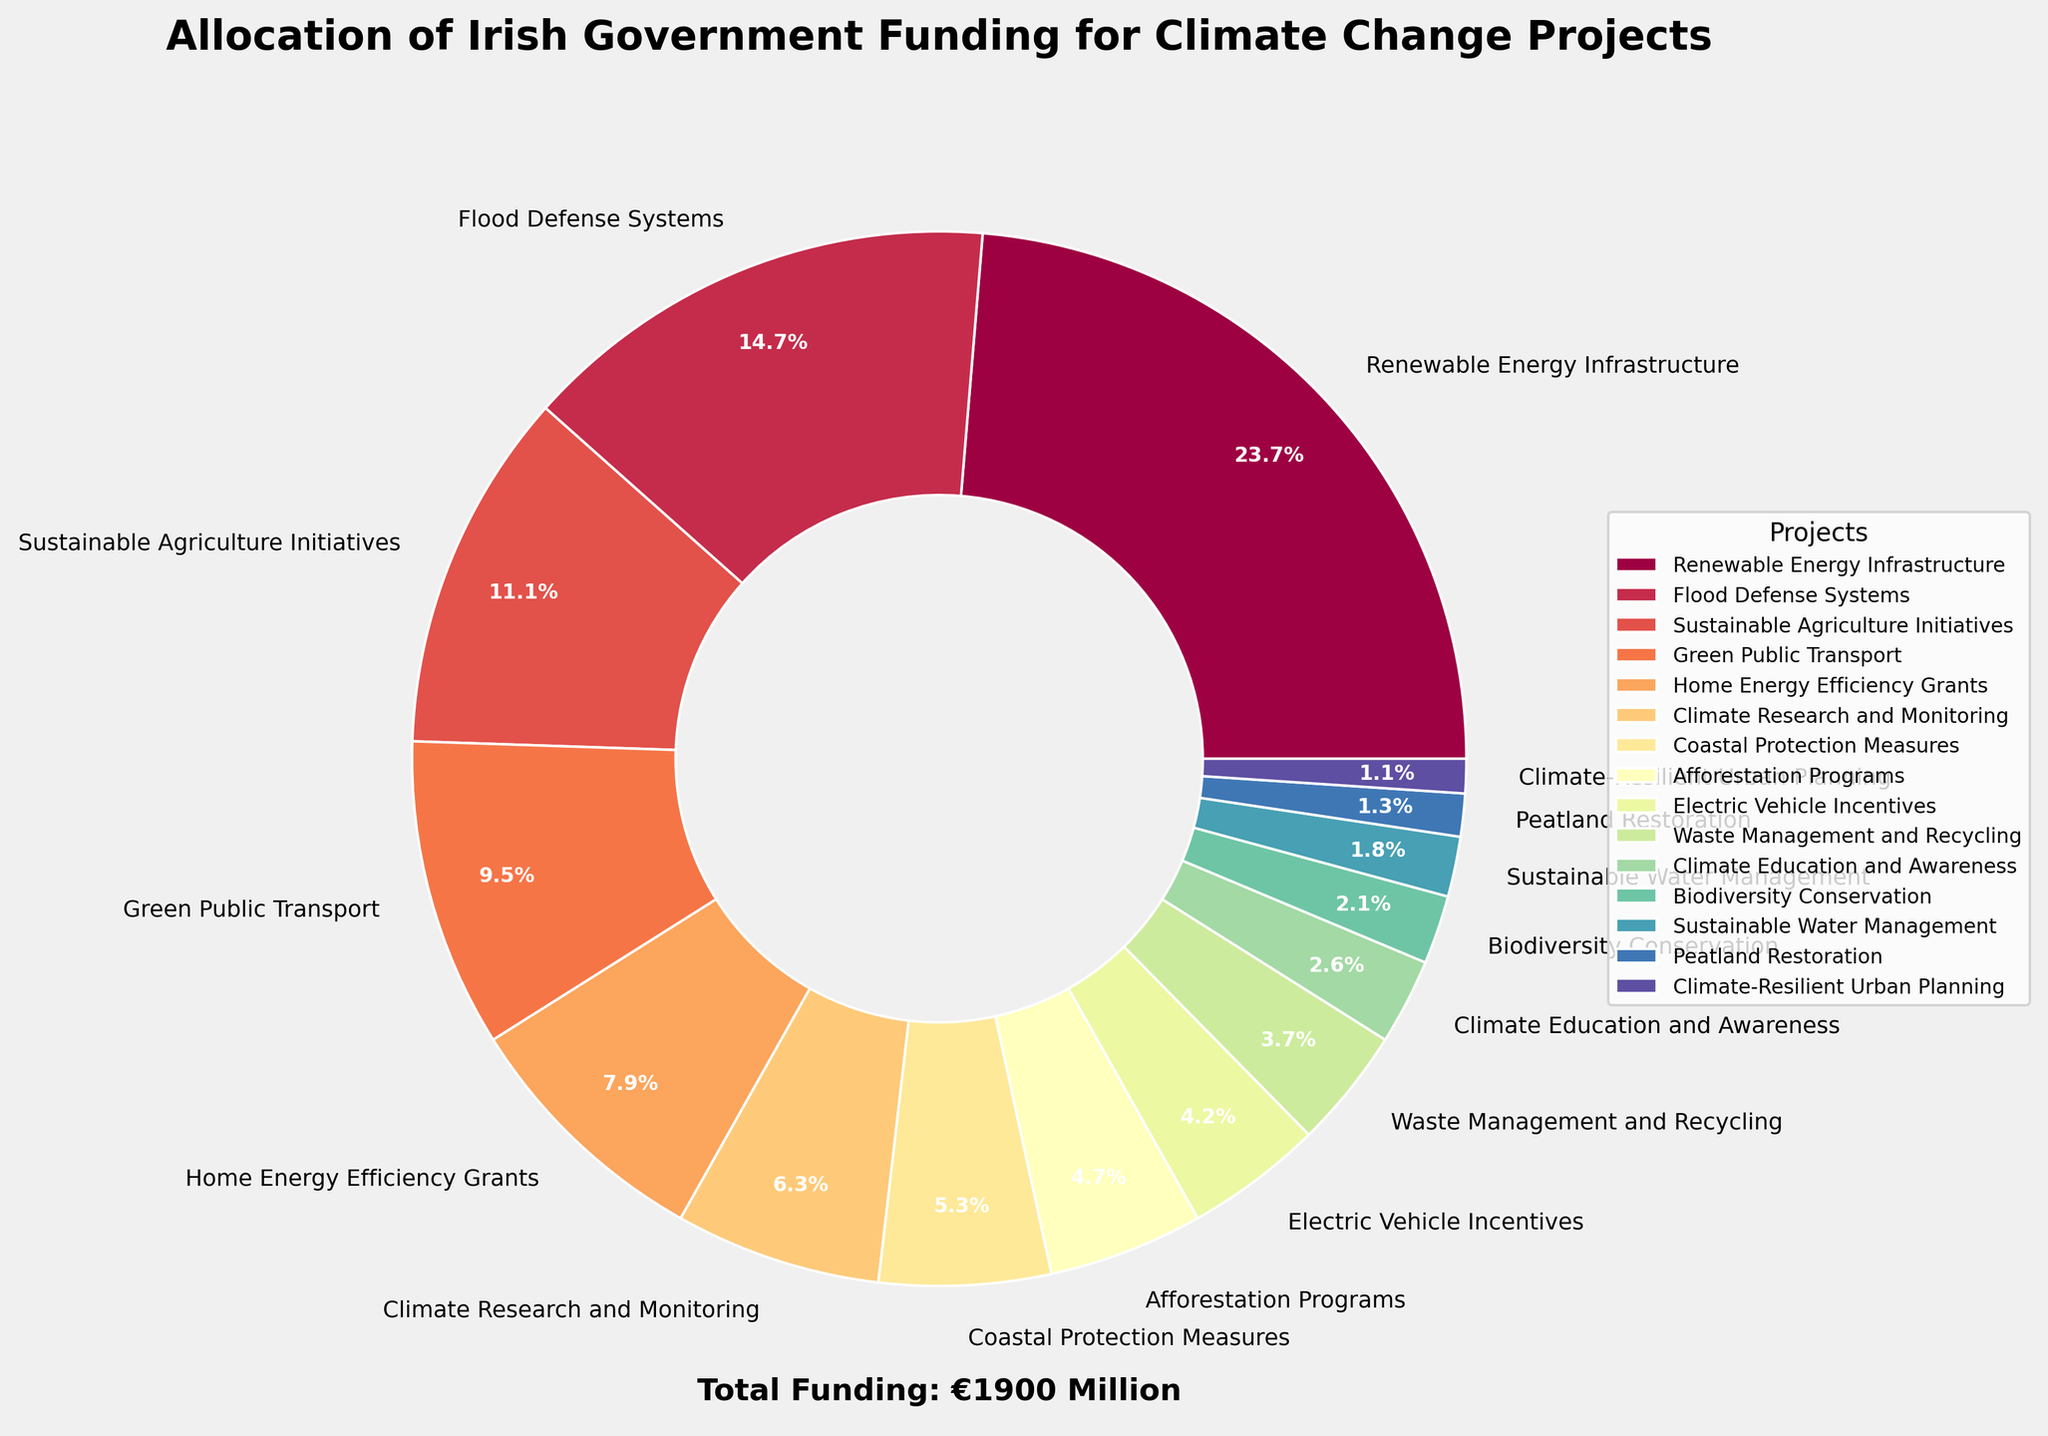Which project received the highest funding? The pie chart indicates that the largest slice corresponds to Renewable Energy Infrastructure.
Answer: Renewable Energy Infrastructure What is the funding gap between Renewable Energy Infrastructure and Flood Defense Systems? Renewable Energy Infrastructure received €450 million, while Flood Defense Systems got €280 million. The difference is 450 - 280 = 170.
Answer: €170 million How much total funding was allocated to Green Public Transport and Home Energy Efficiency Grants? Green Public Transport received €180 million, and Home Energy Efficiency Grants received €150 million. The total is 180 + 150 = 330.
Answer: €330 million Which projects received less funding than Climate Research and Monitoring? Climate Research and Monitoring got €120 million. Lower amounts were allocated to Coastal Protection Measures (€100 million), Afforestation Programs (€90 million), Electric Vehicle Incentives (€80 million), and so on.
Answer: Coastal Protection Measures, Afforestation Programs, Electric Vehicle Incentives, Waste Management and Recycling, Climate Education and Awareness, Biodiversity Conservation, Sustainable Water Management, Peatland Restoration, Climate-Resilient Urban Planning What percentage of the total funding is allocated to Afforestation Programs? The pie chart shows percentages, and Afforestation Programs received 90 / 1860 * 100 ≈ 4.8%.
Answer: ≈ 4.8% What is the total funding for projects receiving more than €100 million each? The projects receiving more than €100 million are Renewable Energy Infrastructure (€450 million), Flood Defense Systems (€280 million), Sustainable Agriculture Initiatives (€210 million), Green Public Transport (€180 million), Home Energy Efficiency Grants (€150 million), and Climate Research and Monitoring (€120 million). Summing these gives 450 + 280 + 210 + 180 + 150 + 120 = 1390.
Answer: €1390 million Which project received the least funding? The pie chart indicates the smallest slice corresponds to Climate-Resilient Urban Planning.
Answer: Climate-Resilient Urban Planning How does the funding for Coastal Protection Measures compare to that for Electric Vehicle Incentives? Coastal Protection Measures received €100 million, while Electric Vehicle Incentives got €80 million. Coastal Protection Measures received €20 million more.
Answer: €20 million more What is the combined funding for Climate Education and Awareness and Biodiversity Conservation? Climate Education and Awareness received €50 million, and Biodiversity Conservation got €40 million. The combined funding is 50 + 40 = 90.
Answer: €90 million What is the average funding allocated to the projects? The total funding is €1860 million, and there are 15 projects. The average funding is 1860 / 15 = 124.
Answer: €124 million 